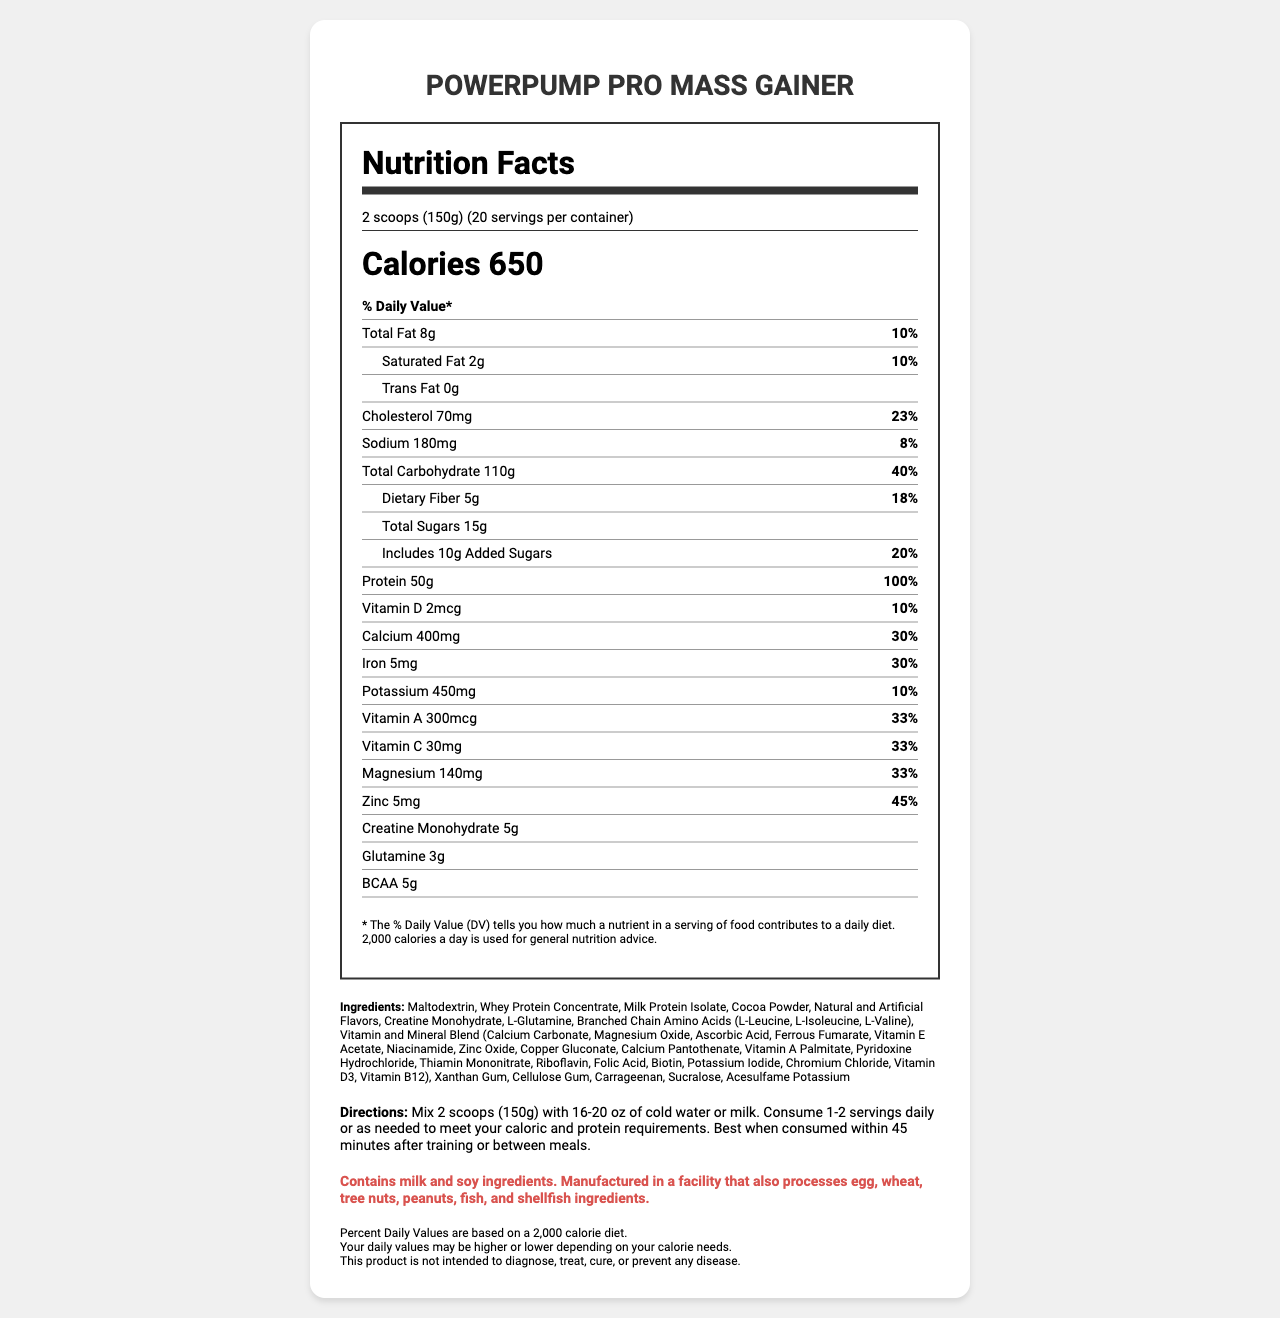what is the serving size of the PowerPump Pro Mass Gainer? The serving size is clearly listed in the nutrition facts label at the top of the document.
Answer: 2 scoops (150g) how many calories are in each serving? The calorie content per serving is shown prominently in the document as "Calories 650".
Answer: 650 calories what is the total carbohydrate content per serving? The total carbohydrate content per serving is listed as 110g in the nutrition facts section of the document.
Answer: 110g how much protein is in each serving? The amount of protein per serving is stated as 50g in the nutrition facts.
Answer: 50g what percentage of the daily value for cholesterol does each serving provide? Under the cholesterol section, it lists "23%" as the percent daily value for cholesterol.
Answer: 23% which of the following nutrients is present in the highest quantity per serving? 
A. Protein
B. Total Carbohydrate
C. Total Fat
D. Total Sugars The document shows 110g for Total Carbohydrate, which is higher than the amounts for Protein, Total Fat, and Total Sugars.
Answer: B. Total Carbohydrate how much dietary fiber is in each serving? 
A. 3g
B. 5g
C. 7g
D. 10g The document states that each serving contains 5g of dietary fiber.
Answer: B. 5g is there any trans fat in this mass gainer shake? The document lists the trans fat content as "0g".
Answer: No are the daily values of all nutrients the same for everyone? why or why not? The document includes disclaimers stating that percent daily values are based on a 2,000 calorie diet and that individual daily values may vary based on different calorie needs.
Answer: No summarize the main nutritional features of the PowerPump Pro Mass Gainer. This explanation captures the key nutritional aspects such as calorie content, macronutrient breakdown (carbohydrates and protein), additional performance-enhancing ingredients, and essential vitamins and minerals.
Answer: The PowerPump Pro Mass Gainer provides a high-calorie supplement with 650 calories per serving. It is rich in carbohydrates (110g), protein (50g), and contains essential vitamins and minerals. The product is designed to support mass gain and recovery with added ingredients like creatine monohydrate, glutamine, and BCAAs. It also contains 15g of sugars and 5g of dietary fiber per serving. what is the company's address? The document does not provide any information about the company's address or contact details.
Answer: Cannot be determined 